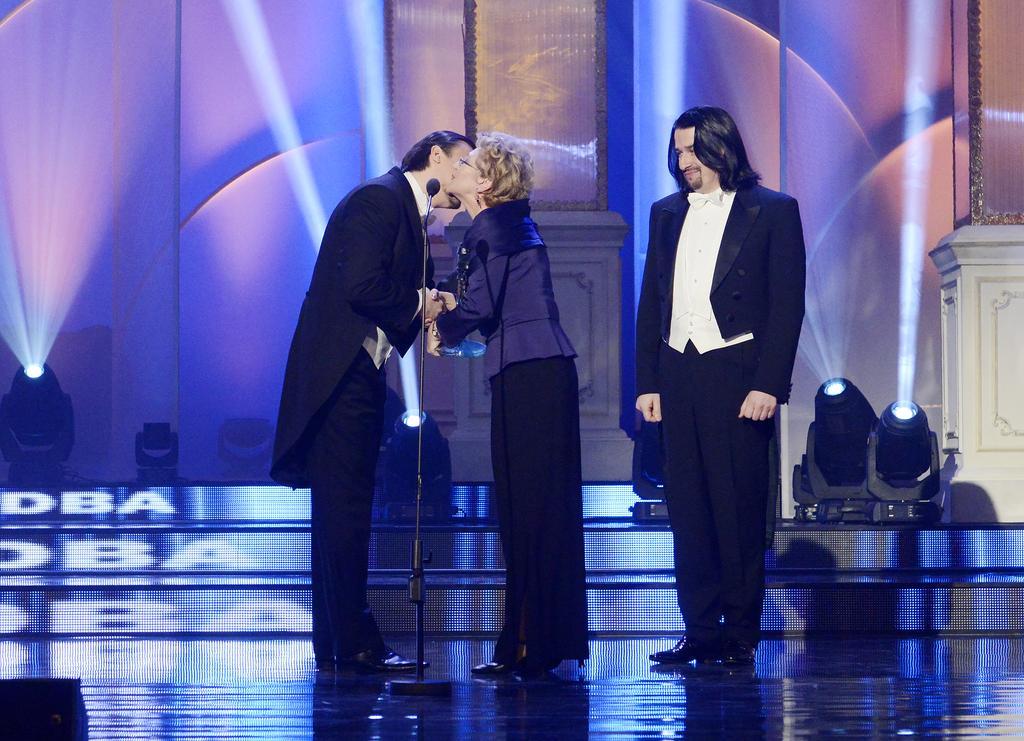How would you summarize this image in a sentence or two? Here I can see two men and a woman are standing on the stage. The woman is holding an object in the hand. In front of these people there is a mike stand. In the background there are few lights placed on the stage. 